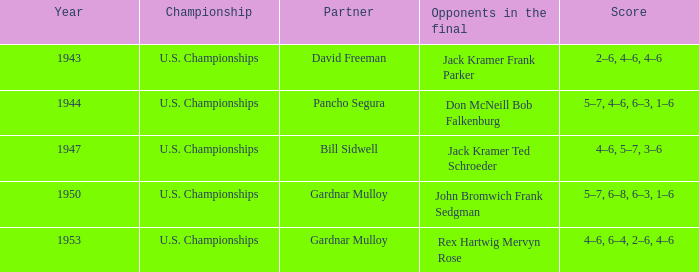Which Opponents in the final have a Score of 4–6, 6–4, 2–6, 4–6? Rex Hartwig Mervyn Rose. 